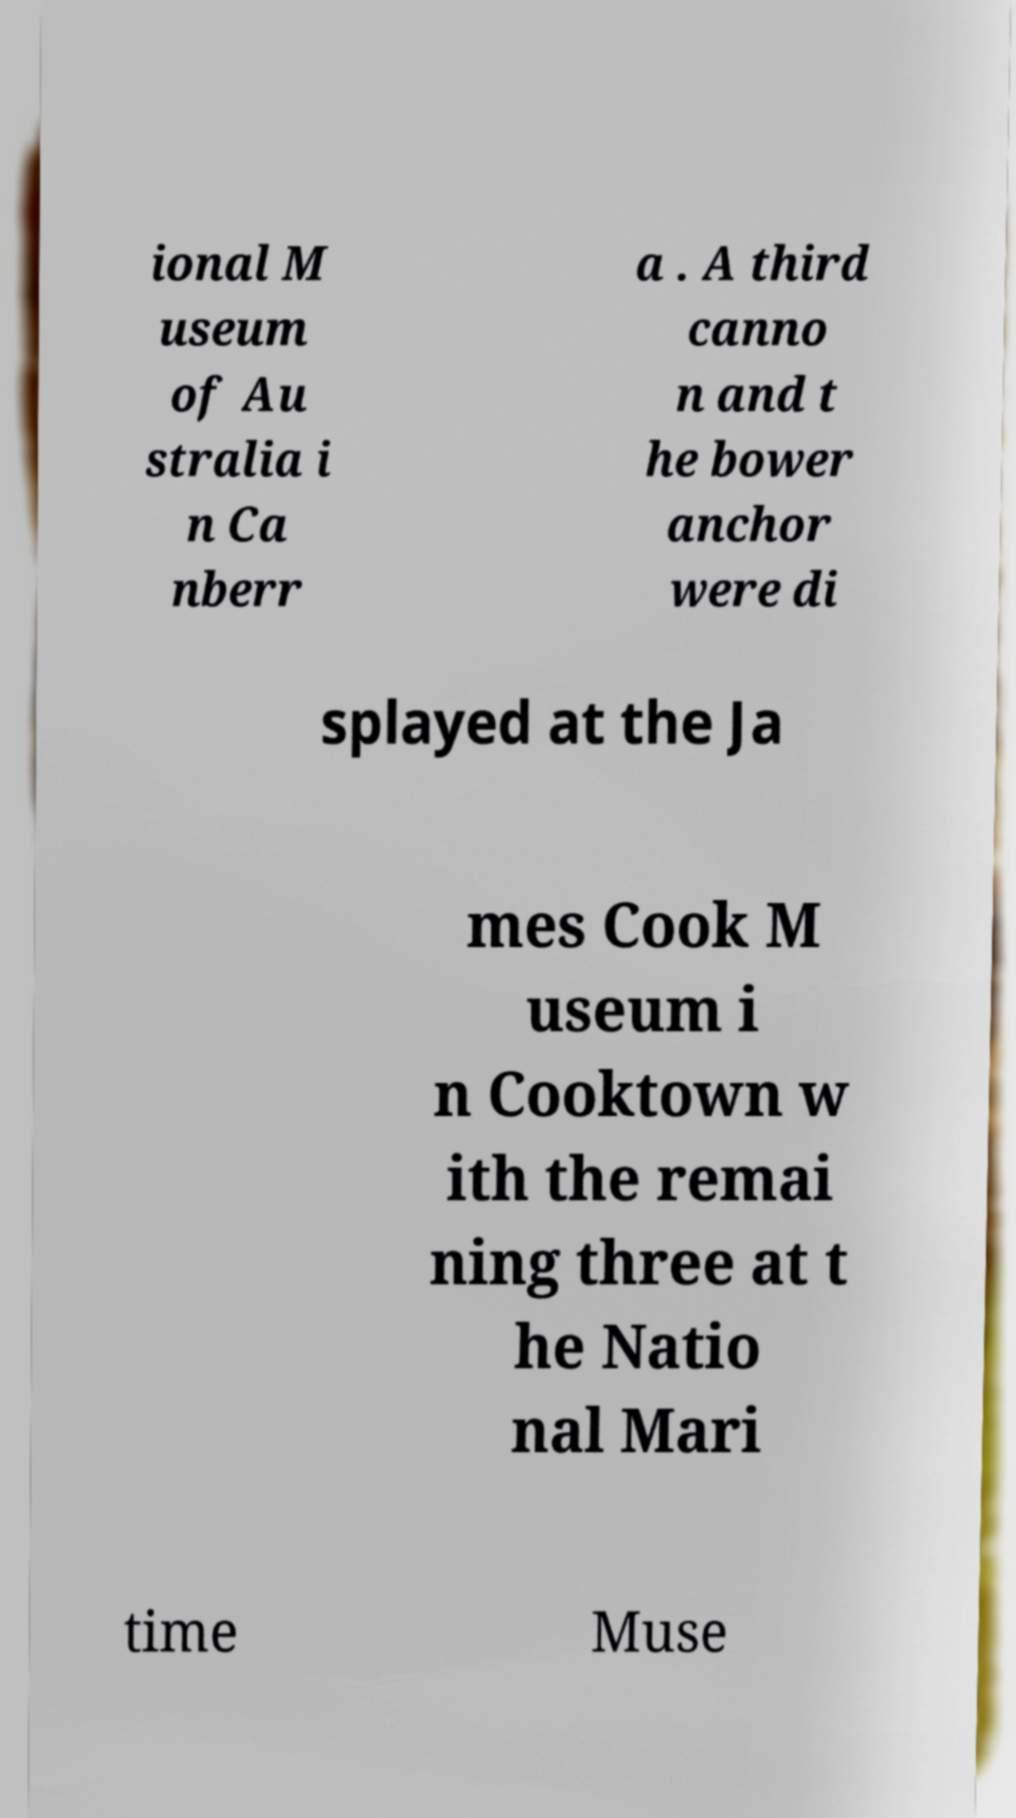Can you read and provide the text displayed in the image?This photo seems to have some interesting text. Can you extract and type it out for me? ional M useum of Au stralia i n Ca nberr a . A third canno n and t he bower anchor were di splayed at the Ja mes Cook M useum i n Cooktown w ith the remai ning three at t he Natio nal Mari time Muse 